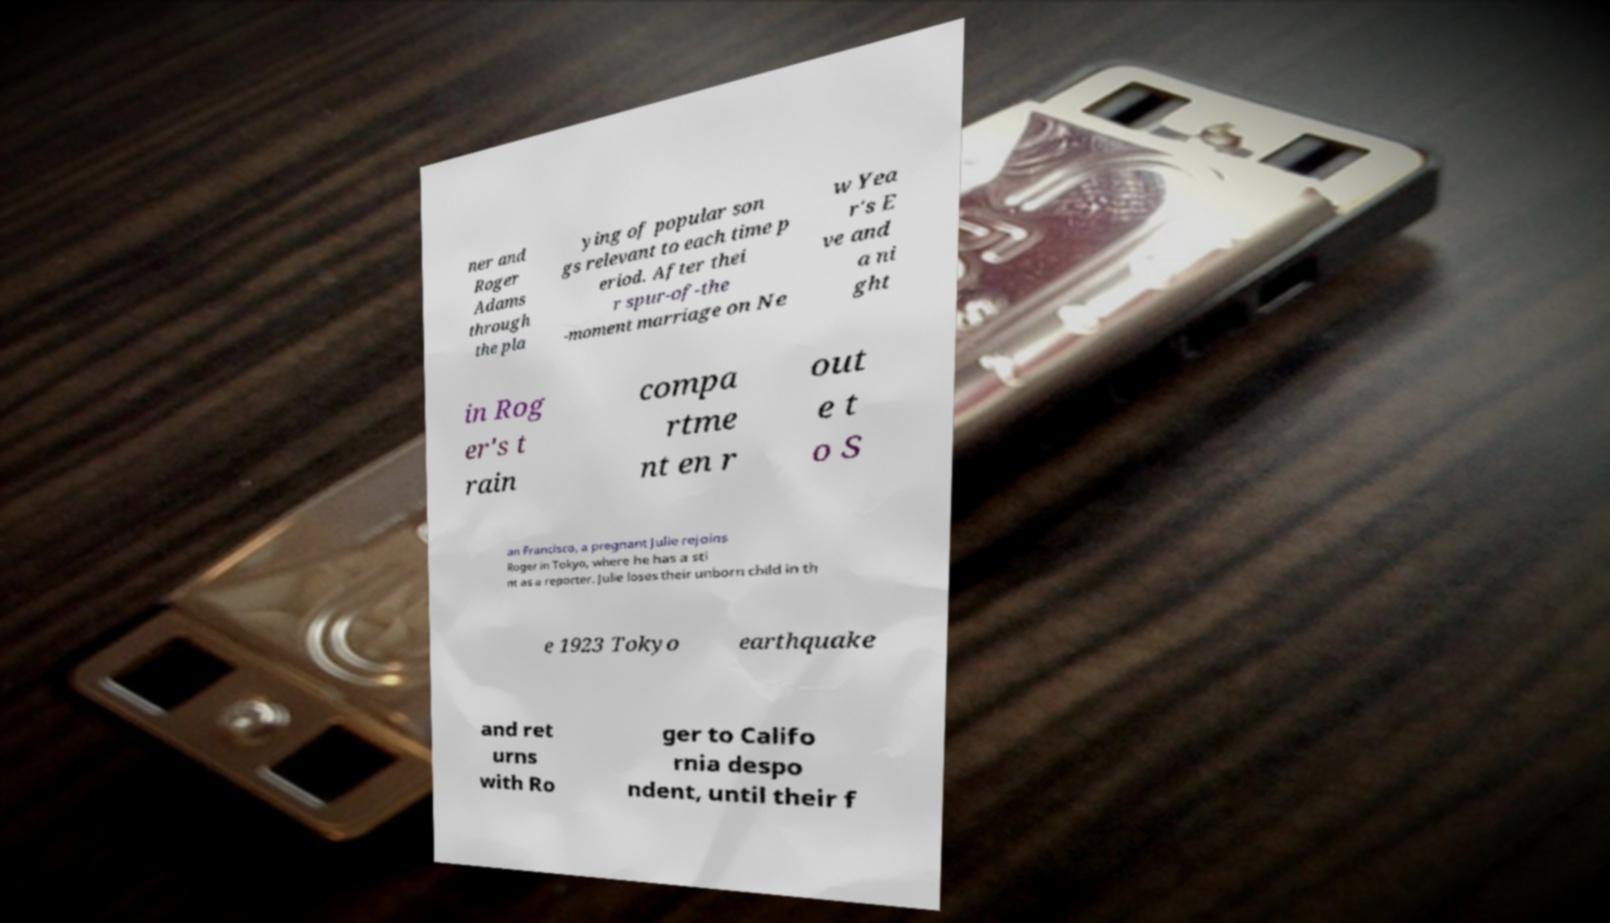I need the written content from this picture converted into text. Can you do that? ner and Roger Adams through the pla ying of popular son gs relevant to each time p eriod. After thei r spur-of-the -moment marriage on Ne w Yea r's E ve and a ni ght in Rog er's t rain compa rtme nt en r out e t o S an Francisco, a pregnant Julie rejoins Roger in Tokyo, where he has a sti nt as a reporter. Julie loses their unborn child in th e 1923 Tokyo earthquake and ret urns with Ro ger to Califo rnia despo ndent, until their f 